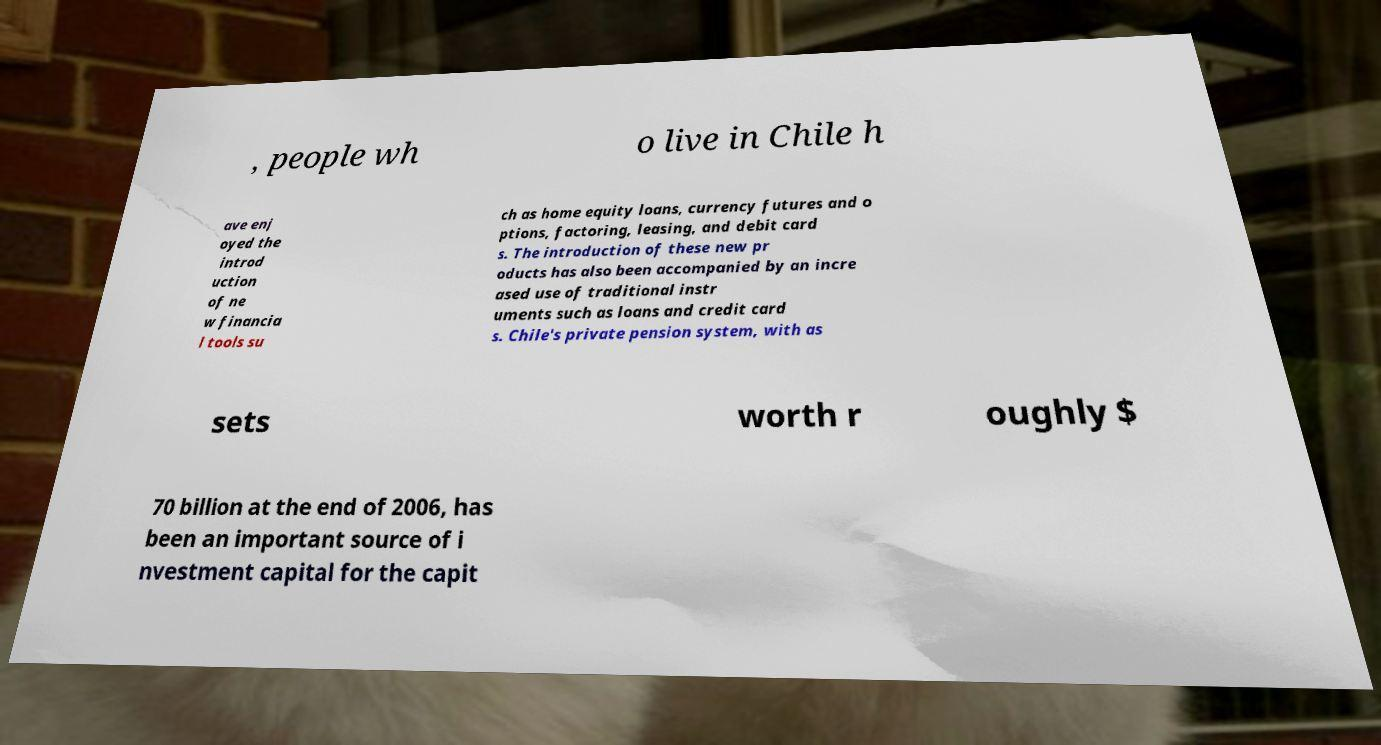I need the written content from this picture converted into text. Can you do that? , people wh o live in Chile h ave enj oyed the introd uction of ne w financia l tools su ch as home equity loans, currency futures and o ptions, factoring, leasing, and debit card s. The introduction of these new pr oducts has also been accompanied by an incre ased use of traditional instr uments such as loans and credit card s. Chile's private pension system, with as sets worth r oughly $ 70 billion at the end of 2006, has been an important source of i nvestment capital for the capit 